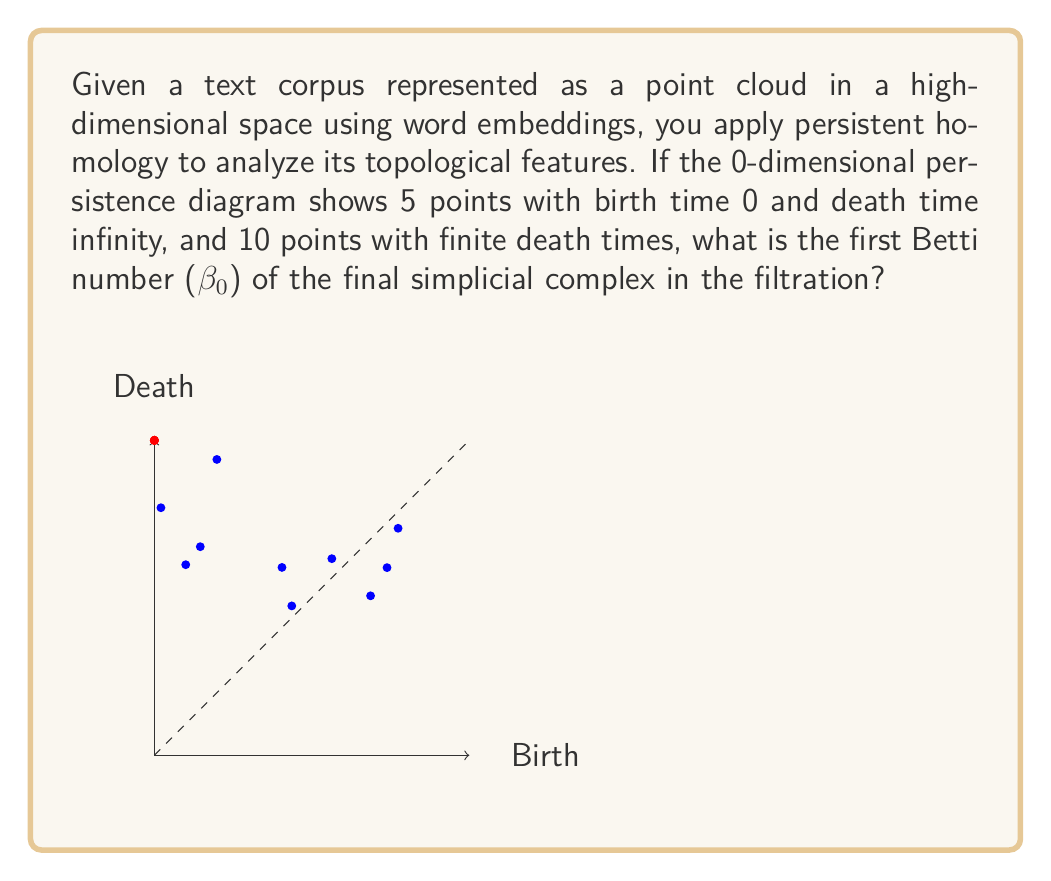Help me with this question. To solve this problem, we need to understand the concept of persistent homology and how it relates to Betti numbers. Let's break it down step-by-step:

1) In persistent homology, the 0-dimensional persistence diagram represents the birth and death of connected components in the filtration.

2) Points with birth time 0 and death time infinity represent components that persist throughout the entire filtration. These correspond to the final connected components in the simplicial complex.

3) The number of points with birth time 0 and death time infinity is equal to the 0-dimensional Betti number ($\beta_0$) of the final simplicial complex.

4) In this case, we have 5 points with birth time 0 and death time infinity. This means there are 5 connected components that persist until the end of the filtration.

5) The 10 points with finite death times represent components that merge with other components during the filtration process. These do not contribute to the final Betti number.

6) Therefore, the 0-dimensional Betti number ($\beta_0$) of the final simplicial complex is equal to the number of points with infinite death time, which is 5.

This result indicates that the text corpus, when represented as a point cloud in the embedding space, forms 5 distinct clusters or topics that remain separate throughout the entire filtration process.
Answer: $\beta_0 = 5$ 